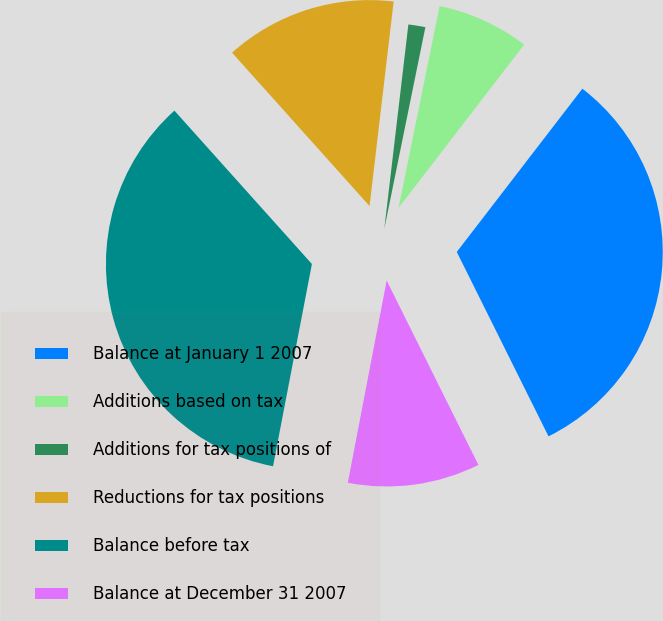Convert chart. <chart><loc_0><loc_0><loc_500><loc_500><pie_chart><fcel>Balance at January 1 2007<fcel>Additions based on tax<fcel>Additions for tax positions of<fcel>Reductions for tax positions<fcel>Balance before tax<fcel>Balance at December 31 2007<nl><fcel>32.22%<fcel>7.24%<fcel>1.33%<fcel>13.5%<fcel>35.35%<fcel>10.37%<nl></chart> 